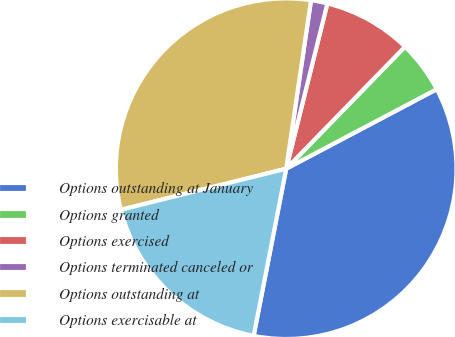Convert chart to OTSL. <chart><loc_0><loc_0><loc_500><loc_500><pie_chart><fcel>Options outstanding at January<fcel>Options granted<fcel>Options exercised<fcel>Options terminated canceled or<fcel>Options outstanding at<fcel>Options exercisable at<nl><fcel>35.8%<fcel>4.98%<fcel>8.4%<fcel>1.56%<fcel>31.21%<fcel>18.06%<nl></chart> 